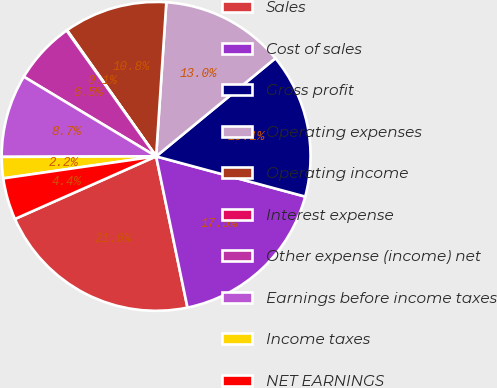Convert chart to OTSL. <chart><loc_0><loc_0><loc_500><loc_500><pie_chart><fcel>Sales<fcel>Cost of sales<fcel>Gross profit<fcel>Operating expenses<fcel>Operating income<fcel>Interest expense<fcel>Other expense (income) net<fcel>Earnings before income taxes<fcel>Income taxes<fcel>NET EARNINGS<nl><fcel>21.61%<fcel>17.55%<fcel>15.15%<fcel>12.99%<fcel>10.84%<fcel>0.06%<fcel>6.53%<fcel>8.68%<fcel>2.22%<fcel>4.37%<nl></chart> 